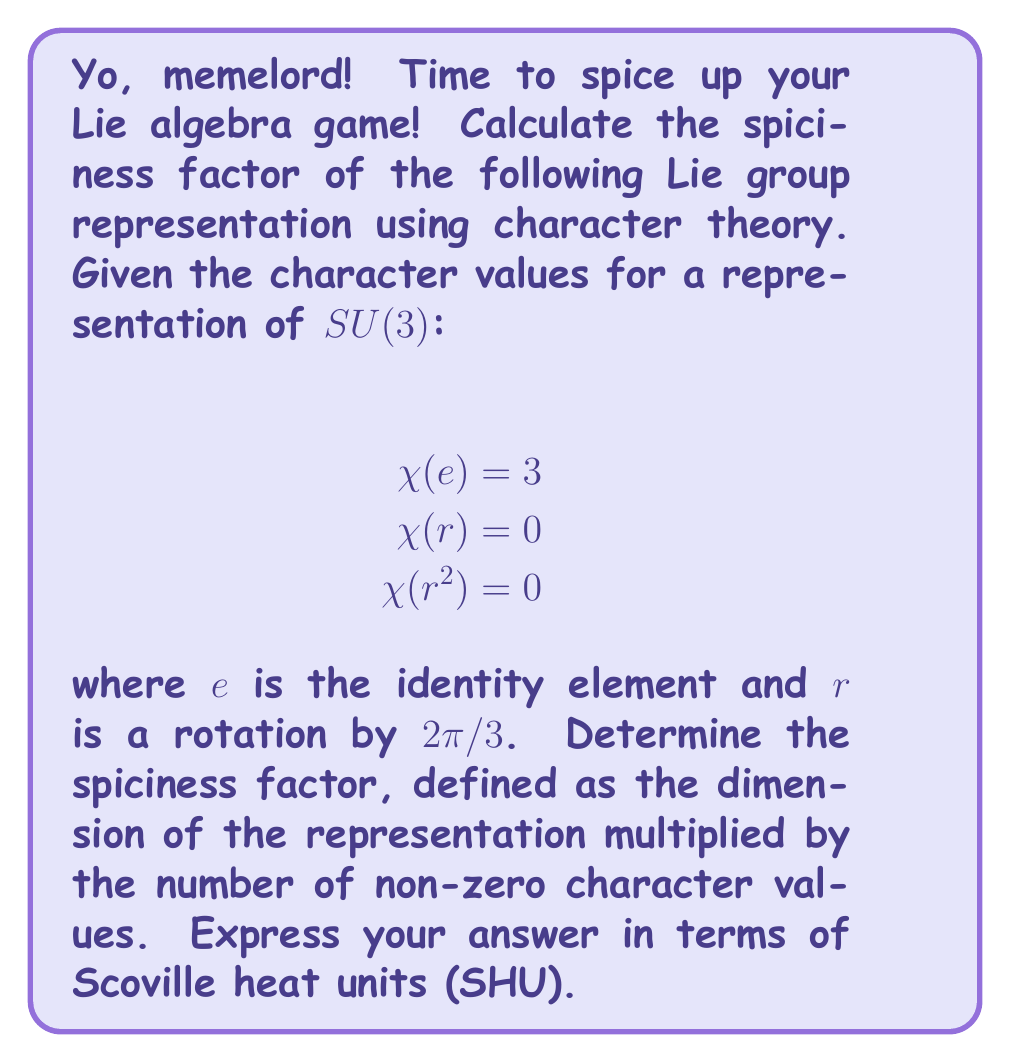Show me your answer to this math problem. Alright, fellow meme enthusiast, let's break this down step by step:

1) First, we need to identify the dimension of the representation. The character value at the identity element $e$ gives us this information:

   $\dim(V) = \chi(e) = 3$

2) Next, we count the number of non-zero character values:
   - $\chi(e) = 3$ (non-zero)
   - $\chi(r) = 0$ (zero)
   - $\chi(r^2) = 0$ (zero)

   So we have 1 non-zero character value.

3) Now, let's define our spiciness factor $S$:

   $S = \dim(V) \times (\text{number of non-zero character values})$

4) Plugging in our values:

   $S = 3 \times 1 = 3$

5) To express this in Scoville heat units (SHU), we'll multiply by $10^6$ (because memes are always extra):

   $S_{SHU} = 3 \times 10^6 = 3,000,000$ SHU

Fun fact: This is about as spicy as a Carolina Reaper pepper! 🌶️🔥
Answer: 3,000,000 SHU 